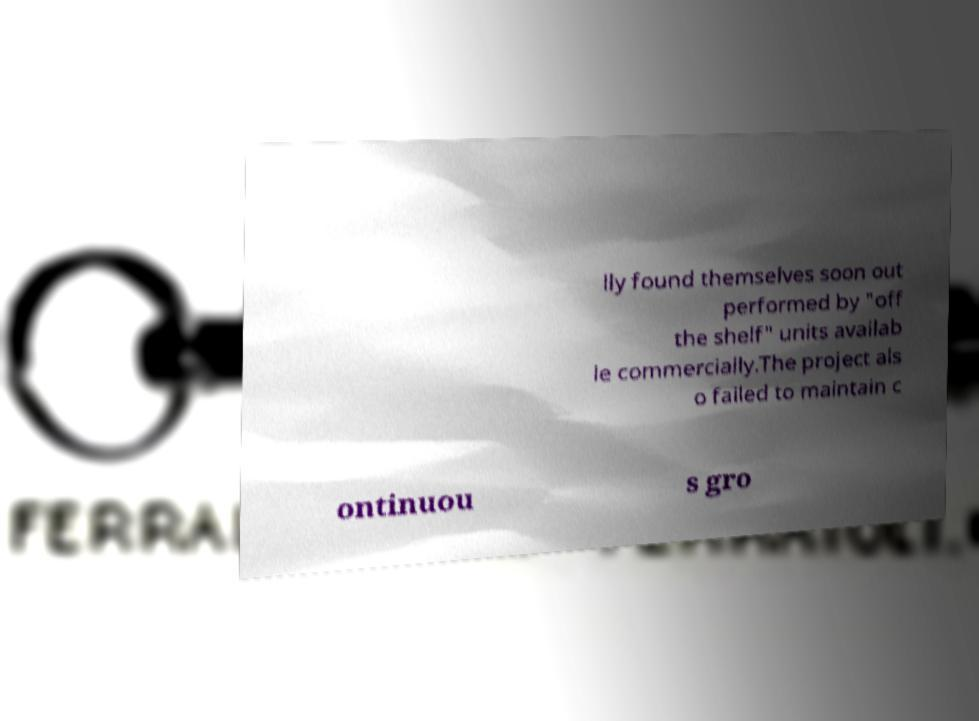I need the written content from this picture converted into text. Can you do that? lly found themselves soon out performed by "off the shelf" units availab le commercially.The project als o failed to maintain c ontinuou s gro 